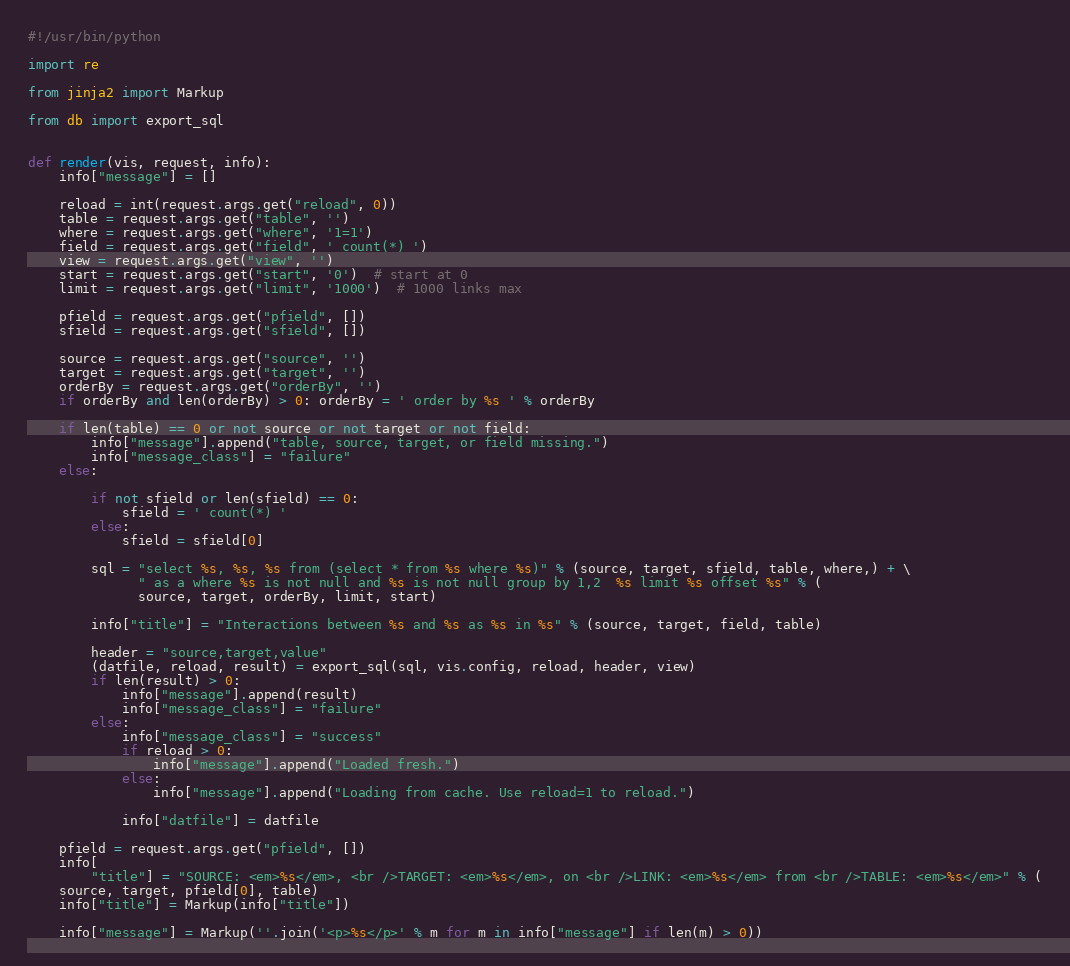<code> <loc_0><loc_0><loc_500><loc_500><_Python_>#!/usr/bin/python

import re

from jinja2 import Markup

from db import export_sql


def render(vis, request, info):
    info["message"] = []

    reload = int(request.args.get("reload", 0))
    table = request.args.get("table", '')
    where = request.args.get("where", '1=1')
    field = request.args.get("field", ' count(*) ')
    view = request.args.get("view", '')
    start = request.args.get("start", '0')  # start at 0
    limit = request.args.get("limit", '1000')  # 1000 links max

    pfield = request.args.get("pfield", [])
    sfield = request.args.get("sfield", [])

    source = request.args.get("source", '')
    target = request.args.get("target", '')
    orderBy = request.args.get("orderBy", '')
    if orderBy and len(orderBy) > 0: orderBy = ' order by %s ' % orderBy

    if len(table) == 0 or not source or not target or not field:
        info["message"].append("table, source, target, or field missing.")
        info["message_class"] = "failure"
    else:

        if not sfield or len(sfield) == 0:
            sfield = ' count(*) '
        else:
            sfield = sfield[0]

        sql = "select %s, %s, %s from (select * from %s where %s)" % (source, target, sfield, table, where,) + \
              " as a where %s is not null and %s is not null group by 1,2  %s limit %s offset %s" % (
              source, target, orderBy, limit, start)

        info["title"] = "Interactions between %s and %s as %s in %s" % (source, target, field, table)

        header = "source,target,value"
        (datfile, reload, result) = export_sql(sql, vis.config, reload, header, view)
        if len(result) > 0:
            info["message"].append(result)
            info["message_class"] = "failure"
        else:
            info["message_class"] = "success"
            if reload > 0:
                info["message"].append("Loaded fresh.")
            else:
                info["message"].append("Loading from cache. Use reload=1 to reload.")

            info["datfile"] = datfile

    pfield = request.args.get("pfield", [])
    info[
        "title"] = "SOURCE: <em>%s</em>, <br />TARGET: <em>%s</em>, on <br />LINK: <em>%s</em> from <br />TABLE: <em>%s</em>" % (
    source, target, pfield[0], table)
    info["title"] = Markup(info["title"])

    info["message"] = Markup(''.join('<p>%s</p>' % m for m in info["message"] if len(m) > 0))
</code> 